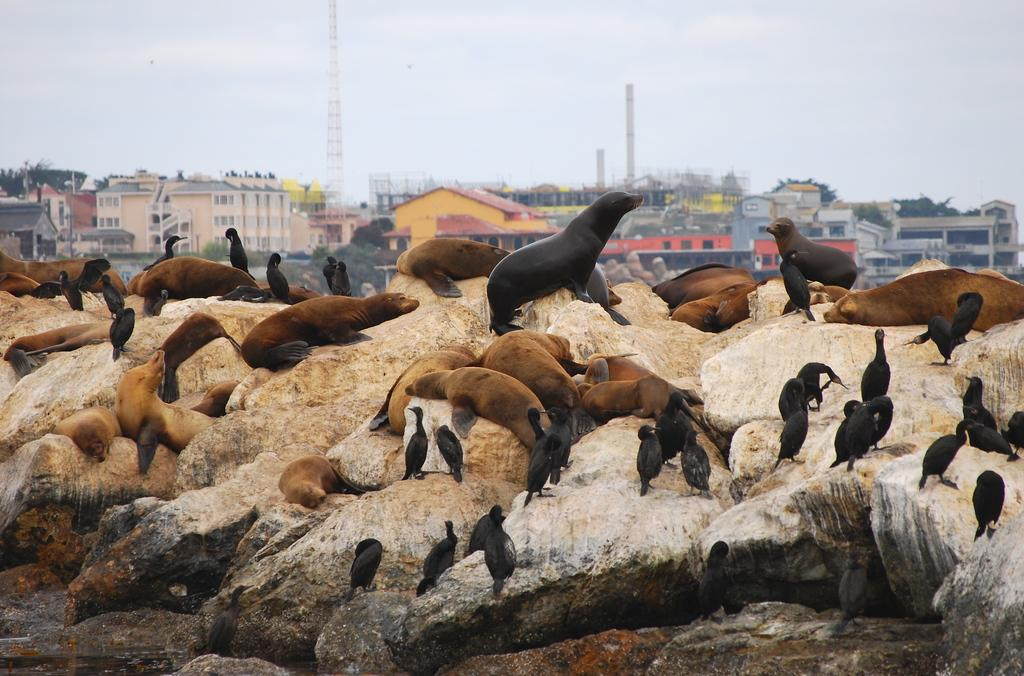What types of living creatures are in the image? There are animals and birds in the image. What colors are the animals and birds? The animals and birds are in black and brown color. Where are the animals and birds located? They are on rocks in the image. What can be seen in the background of the image? There are buildings, towers, and the sky visible in the background of the image. How does the screw help the animals and birds in the image? There is no screw present in the image, so it cannot help the animals and birds. 